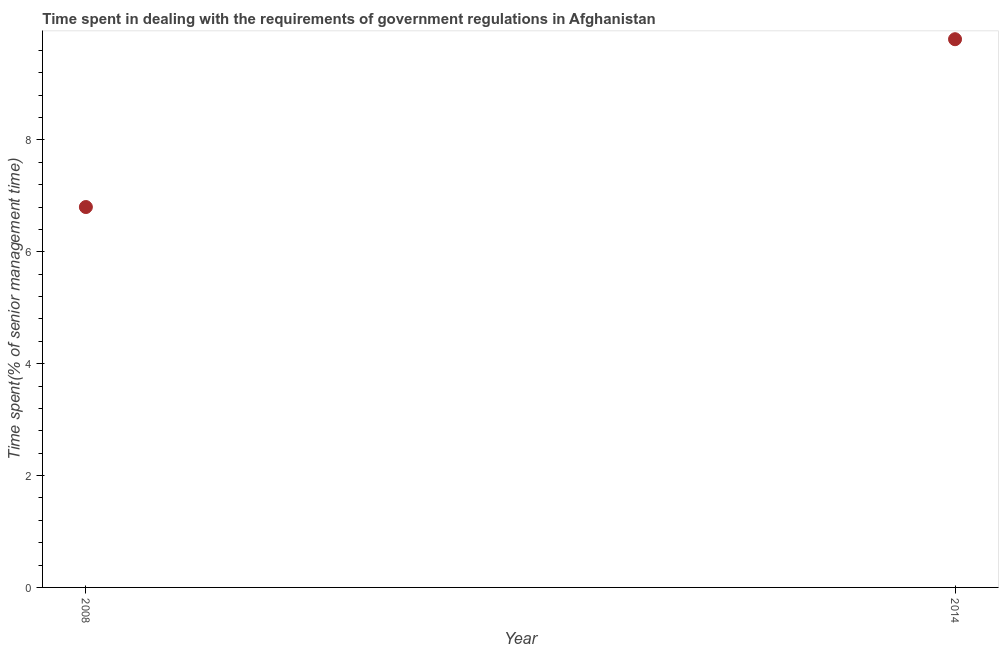Across all years, what is the minimum time spent in dealing with government regulations?
Your answer should be compact. 6.8. In which year was the time spent in dealing with government regulations maximum?
Your answer should be compact. 2014. In which year was the time spent in dealing with government regulations minimum?
Ensure brevity in your answer.  2008. What is the sum of the time spent in dealing with government regulations?
Your response must be concise. 16.6. What is the difference between the time spent in dealing with government regulations in 2008 and 2014?
Give a very brief answer. -3. In how many years, is the time spent in dealing with government regulations greater than 6 %?
Provide a short and direct response. 2. What is the ratio of the time spent in dealing with government regulations in 2008 to that in 2014?
Keep it short and to the point. 0.69. In how many years, is the time spent in dealing with government regulations greater than the average time spent in dealing with government regulations taken over all years?
Provide a short and direct response. 1. How many dotlines are there?
Offer a very short reply. 1. How many years are there in the graph?
Offer a terse response. 2. What is the difference between two consecutive major ticks on the Y-axis?
Give a very brief answer. 2. Does the graph contain any zero values?
Provide a short and direct response. No. What is the title of the graph?
Offer a terse response. Time spent in dealing with the requirements of government regulations in Afghanistan. What is the label or title of the Y-axis?
Your answer should be compact. Time spent(% of senior management time). What is the Time spent(% of senior management time) in 2008?
Offer a terse response. 6.8. What is the difference between the Time spent(% of senior management time) in 2008 and 2014?
Your answer should be very brief. -3. What is the ratio of the Time spent(% of senior management time) in 2008 to that in 2014?
Your response must be concise. 0.69. 